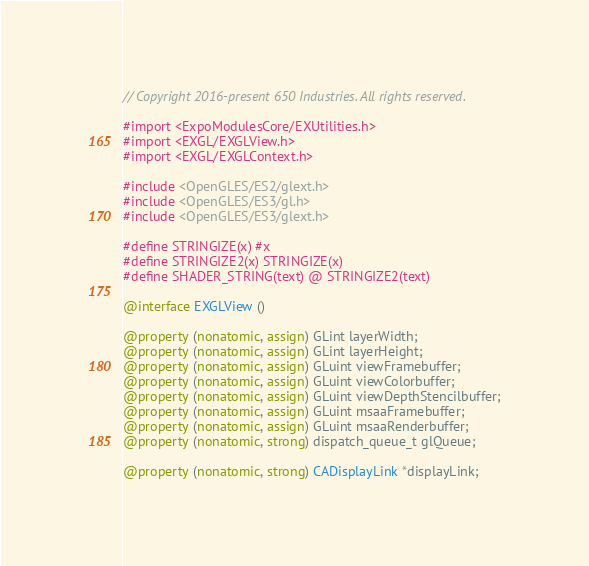<code> <loc_0><loc_0><loc_500><loc_500><_ObjectiveC_>// Copyright 2016-present 650 Industries. All rights reserved.

#import <ExpoModulesCore/EXUtilities.h>
#import <EXGL/EXGLView.h>
#import <EXGL/EXGLContext.h>

#include <OpenGLES/ES2/glext.h>
#include <OpenGLES/ES3/gl.h>
#include <OpenGLES/ES3/glext.h>

#define STRINGIZE(x) #x
#define STRINGIZE2(x) STRINGIZE(x)
#define SHADER_STRING(text) @ STRINGIZE2(text)

@interface EXGLView ()

@property (nonatomic, assign) GLint layerWidth;
@property (nonatomic, assign) GLint layerHeight;
@property (nonatomic, assign) GLuint viewFramebuffer;
@property (nonatomic, assign) GLuint viewColorbuffer;
@property (nonatomic, assign) GLuint viewDepthStencilbuffer;
@property (nonatomic, assign) GLuint msaaFramebuffer;
@property (nonatomic, assign) GLuint msaaRenderbuffer;
@property (nonatomic, strong) dispatch_queue_t glQueue;

@property (nonatomic, strong) CADisplayLink *displayLink;
</code> 